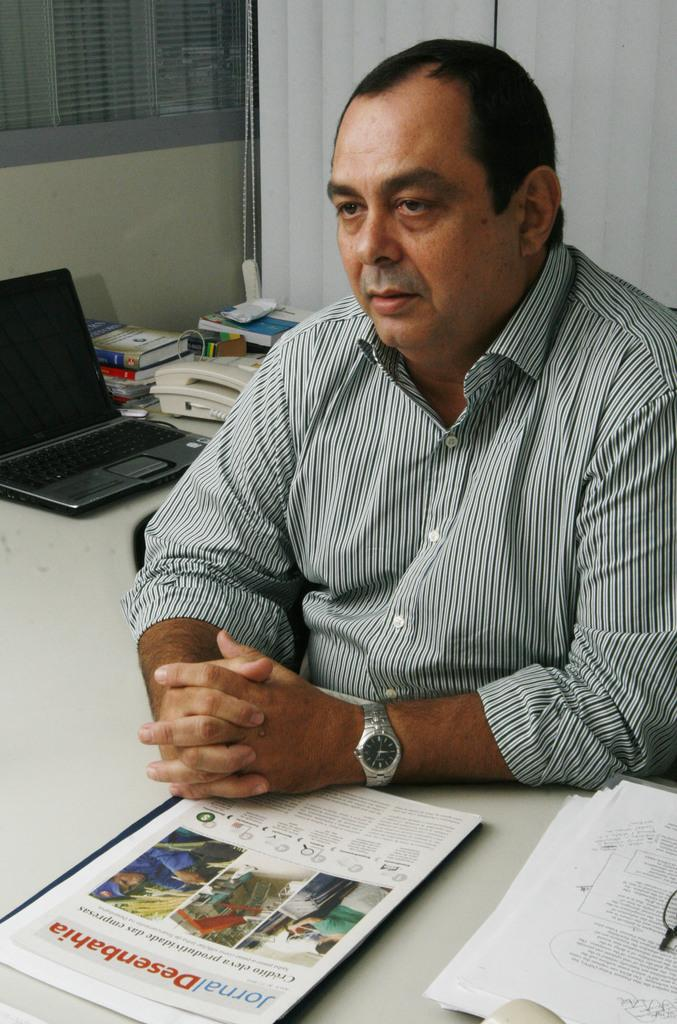<image>
Write a terse but informative summary of the picture. Man sitting with a booklet in front of him that says "Jornal" in blue. 